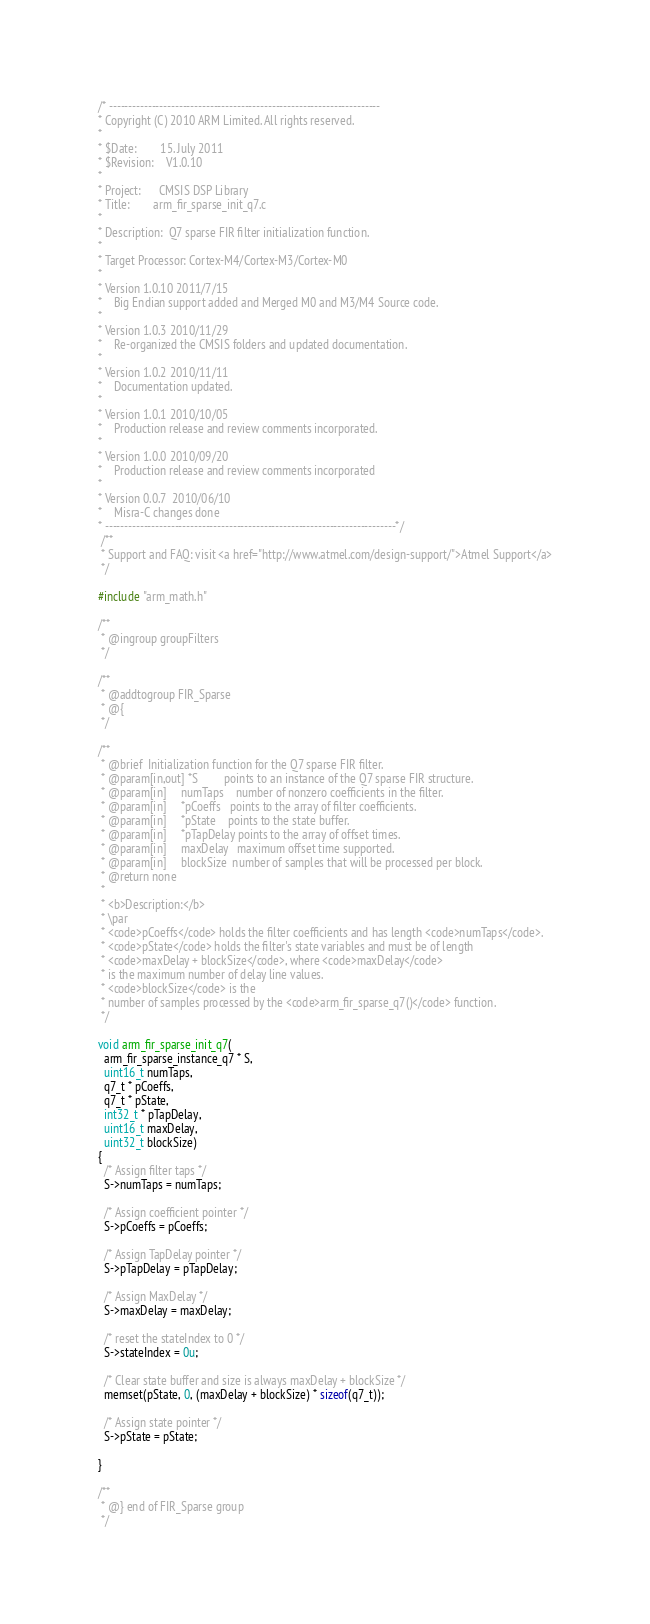<code> <loc_0><loc_0><loc_500><loc_500><_C_>/* ----------------------------------------------------------------------   
* Copyright (C) 2010 ARM Limited. All rights reserved.   
*   
* $Date:        15. July 2011  
* $Revision: 	V1.0.10  
*   
* Project: 	    CMSIS DSP Library   
* Title:        arm_fir_sparse_init_q7.c   
*   
* Description:	Q7 sparse FIR filter initialization function.  
*   
* Target Processor: Cortex-M4/Cortex-M3/Cortex-M0
*  
* Version 1.0.10 2011/7/15 
*    Big Endian support added and Merged M0 and M3/M4 Source code.  
*   
* Version 1.0.3 2010/11/29  
*    Re-organized the CMSIS folders and updated documentation.   
*    
* Version 1.0.2 2010/11/11   
*    Documentation updated.    
*   
* Version 1.0.1 2010/10/05    
*    Production release and review comments incorporated.   
*   
* Version 1.0.0 2010/09/20    
*    Production release and review comments incorporated   
*   
* Version 0.0.7  2010/06/10    
*    Misra-C changes done   
* ---------------------------------------------------------------------------*/
 /**
 * Support and FAQ: visit <a href="http://www.atmel.com/design-support/">Atmel Support</a>
 */

#include "arm_math.h"

/**   
 * @ingroup groupFilters   
 */

/**   
 * @addtogroup FIR_Sparse   
 * @{   
 */

/**  
 * @brief  Initialization function for the Q7 sparse FIR filter.  
 * @param[in,out] *S         points to an instance of the Q7 sparse FIR structure.  
 * @param[in]     numTaps    number of nonzero coefficients in the filter.  
 * @param[in]     *pCoeffs   points to the array of filter coefficients.  
 * @param[in]     *pState    points to the state buffer.  
 * @param[in]     *pTapDelay points to the array of offset times.  
 * @param[in]     maxDelay   maximum offset time supported.  
 * @param[in]     blockSize  number of samples that will be processed per block.  
 * @return none  
 *   
 * <b>Description:</b>   
 * \par   
 * <code>pCoeffs</code> holds the filter coefficients and has length <code>numTaps</code>.   
 * <code>pState</code> holds the filter's state variables and must be of length   
 * <code>maxDelay + blockSize</code>, where <code>maxDelay</code>   
 * is the maximum number of delay line values.   
 * <code>blockSize</code> is the   
 * number of samples processed by the <code>arm_fir_sparse_q7()</code> function.   
 */

void arm_fir_sparse_init_q7(
  arm_fir_sparse_instance_q7 * S,
  uint16_t numTaps,
  q7_t * pCoeffs,
  q7_t * pState,
  int32_t * pTapDelay,
  uint16_t maxDelay,
  uint32_t blockSize)
{
  /* Assign filter taps */
  S->numTaps = numTaps;

  /* Assign coefficient pointer */
  S->pCoeffs = pCoeffs;

  /* Assign TapDelay pointer */
  S->pTapDelay = pTapDelay;

  /* Assign MaxDelay */
  S->maxDelay = maxDelay;

  /* reset the stateIndex to 0 */
  S->stateIndex = 0u;

  /* Clear state buffer and size is always maxDelay + blockSize */
  memset(pState, 0, (maxDelay + blockSize) * sizeof(q7_t));

  /* Assign state pointer */
  S->pState = pState;

}

/**   
 * @} end of FIR_Sparse group   
 */
</code> 